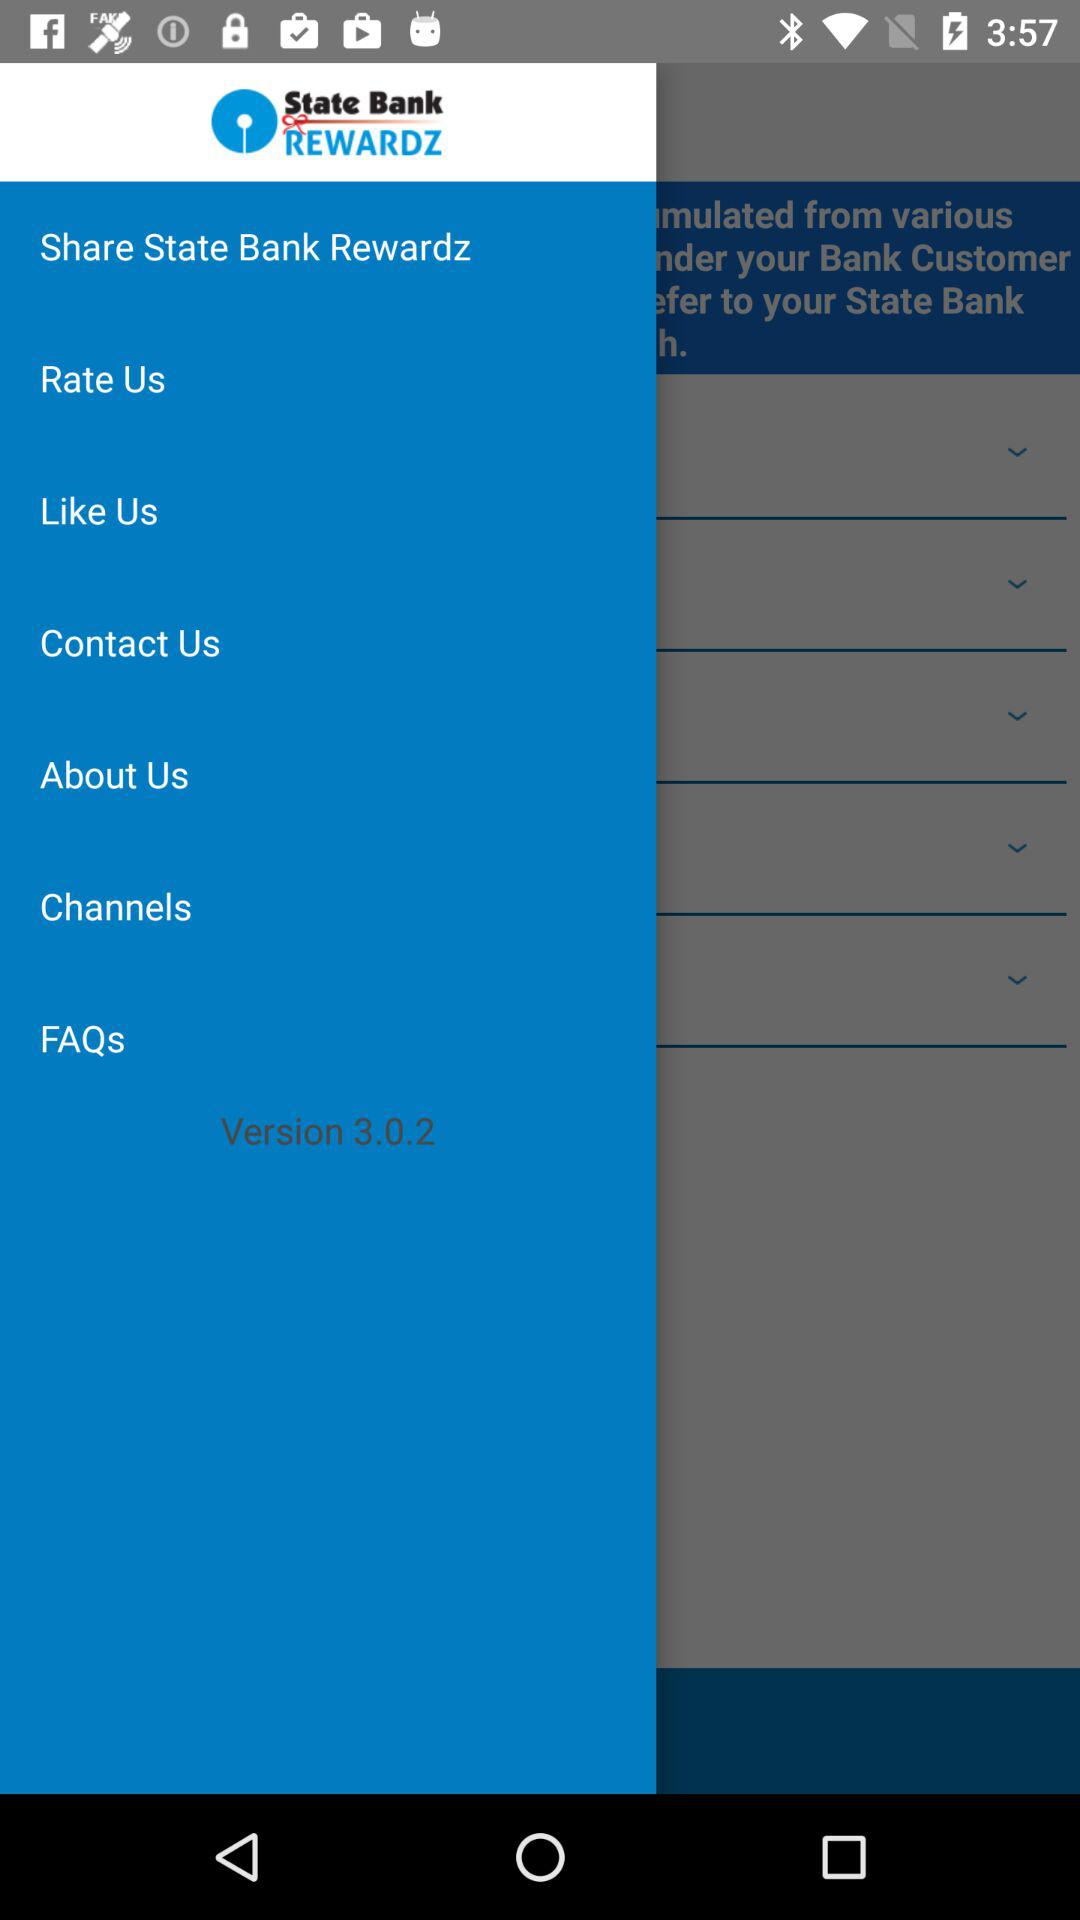What is the contact number?
When the provided information is insufficient, respond with <no answer>. <no answer> 